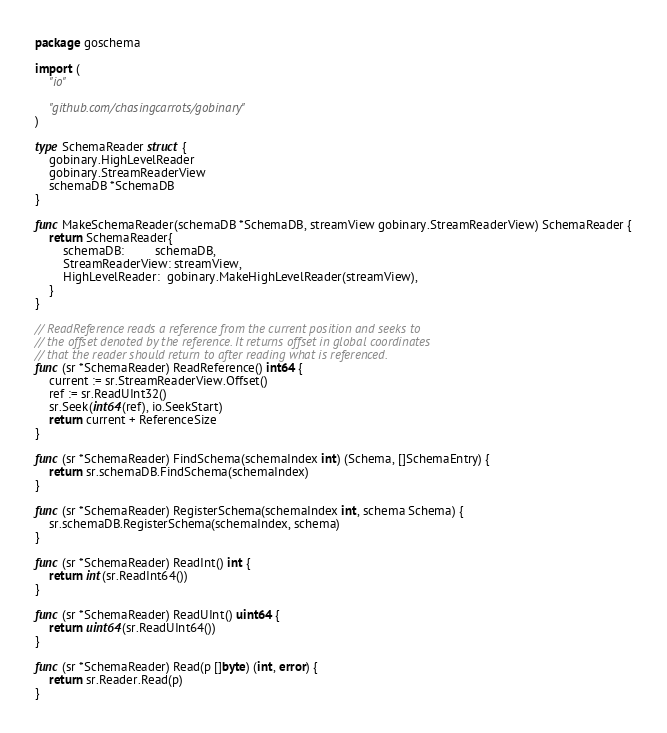Convert code to text. <code><loc_0><loc_0><loc_500><loc_500><_Go_>package goschema

import (
	"io"

	"github.com/chasingcarrots/gobinary"
)

type SchemaReader struct {
	gobinary.HighLevelReader
	gobinary.StreamReaderView
	schemaDB *SchemaDB
}

func MakeSchemaReader(schemaDB *SchemaDB, streamView gobinary.StreamReaderView) SchemaReader {
	return SchemaReader{
		schemaDB:         schemaDB,
		StreamReaderView: streamView,
		HighLevelReader:  gobinary.MakeHighLevelReader(streamView),
	}
}

// ReadReference reads a reference from the current position and seeks to
// the offset denoted by the reference. It returns offset in global coordinates
// that the reader should return to after reading what is referenced.
func (sr *SchemaReader) ReadReference() int64 {
	current := sr.StreamReaderView.Offset()
	ref := sr.ReadUInt32()
	sr.Seek(int64(ref), io.SeekStart)
	return current + ReferenceSize
}

func (sr *SchemaReader) FindSchema(schemaIndex int) (Schema, []SchemaEntry) {
	return sr.schemaDB.FindSchema(schemaIndex)
}

func (sr *SchemaReader) RegisterSchema(schemaIndex int, schema Schema) {
	sr.schemaDB.RegisterSchema(schemaIndex, schema)
}

func (sr *SchemaReader) ReadInt() int {
	return int(sr.ReadInt64())
}

func (sr *SchemaReader) ReadUInt() uint64 {
	return uint64(sr.ReadUInt64())
}

func (sr *SchemaReader) Read(p []byte) (int, error) {
	return sr.Reader.Read(p)
}
</code> 